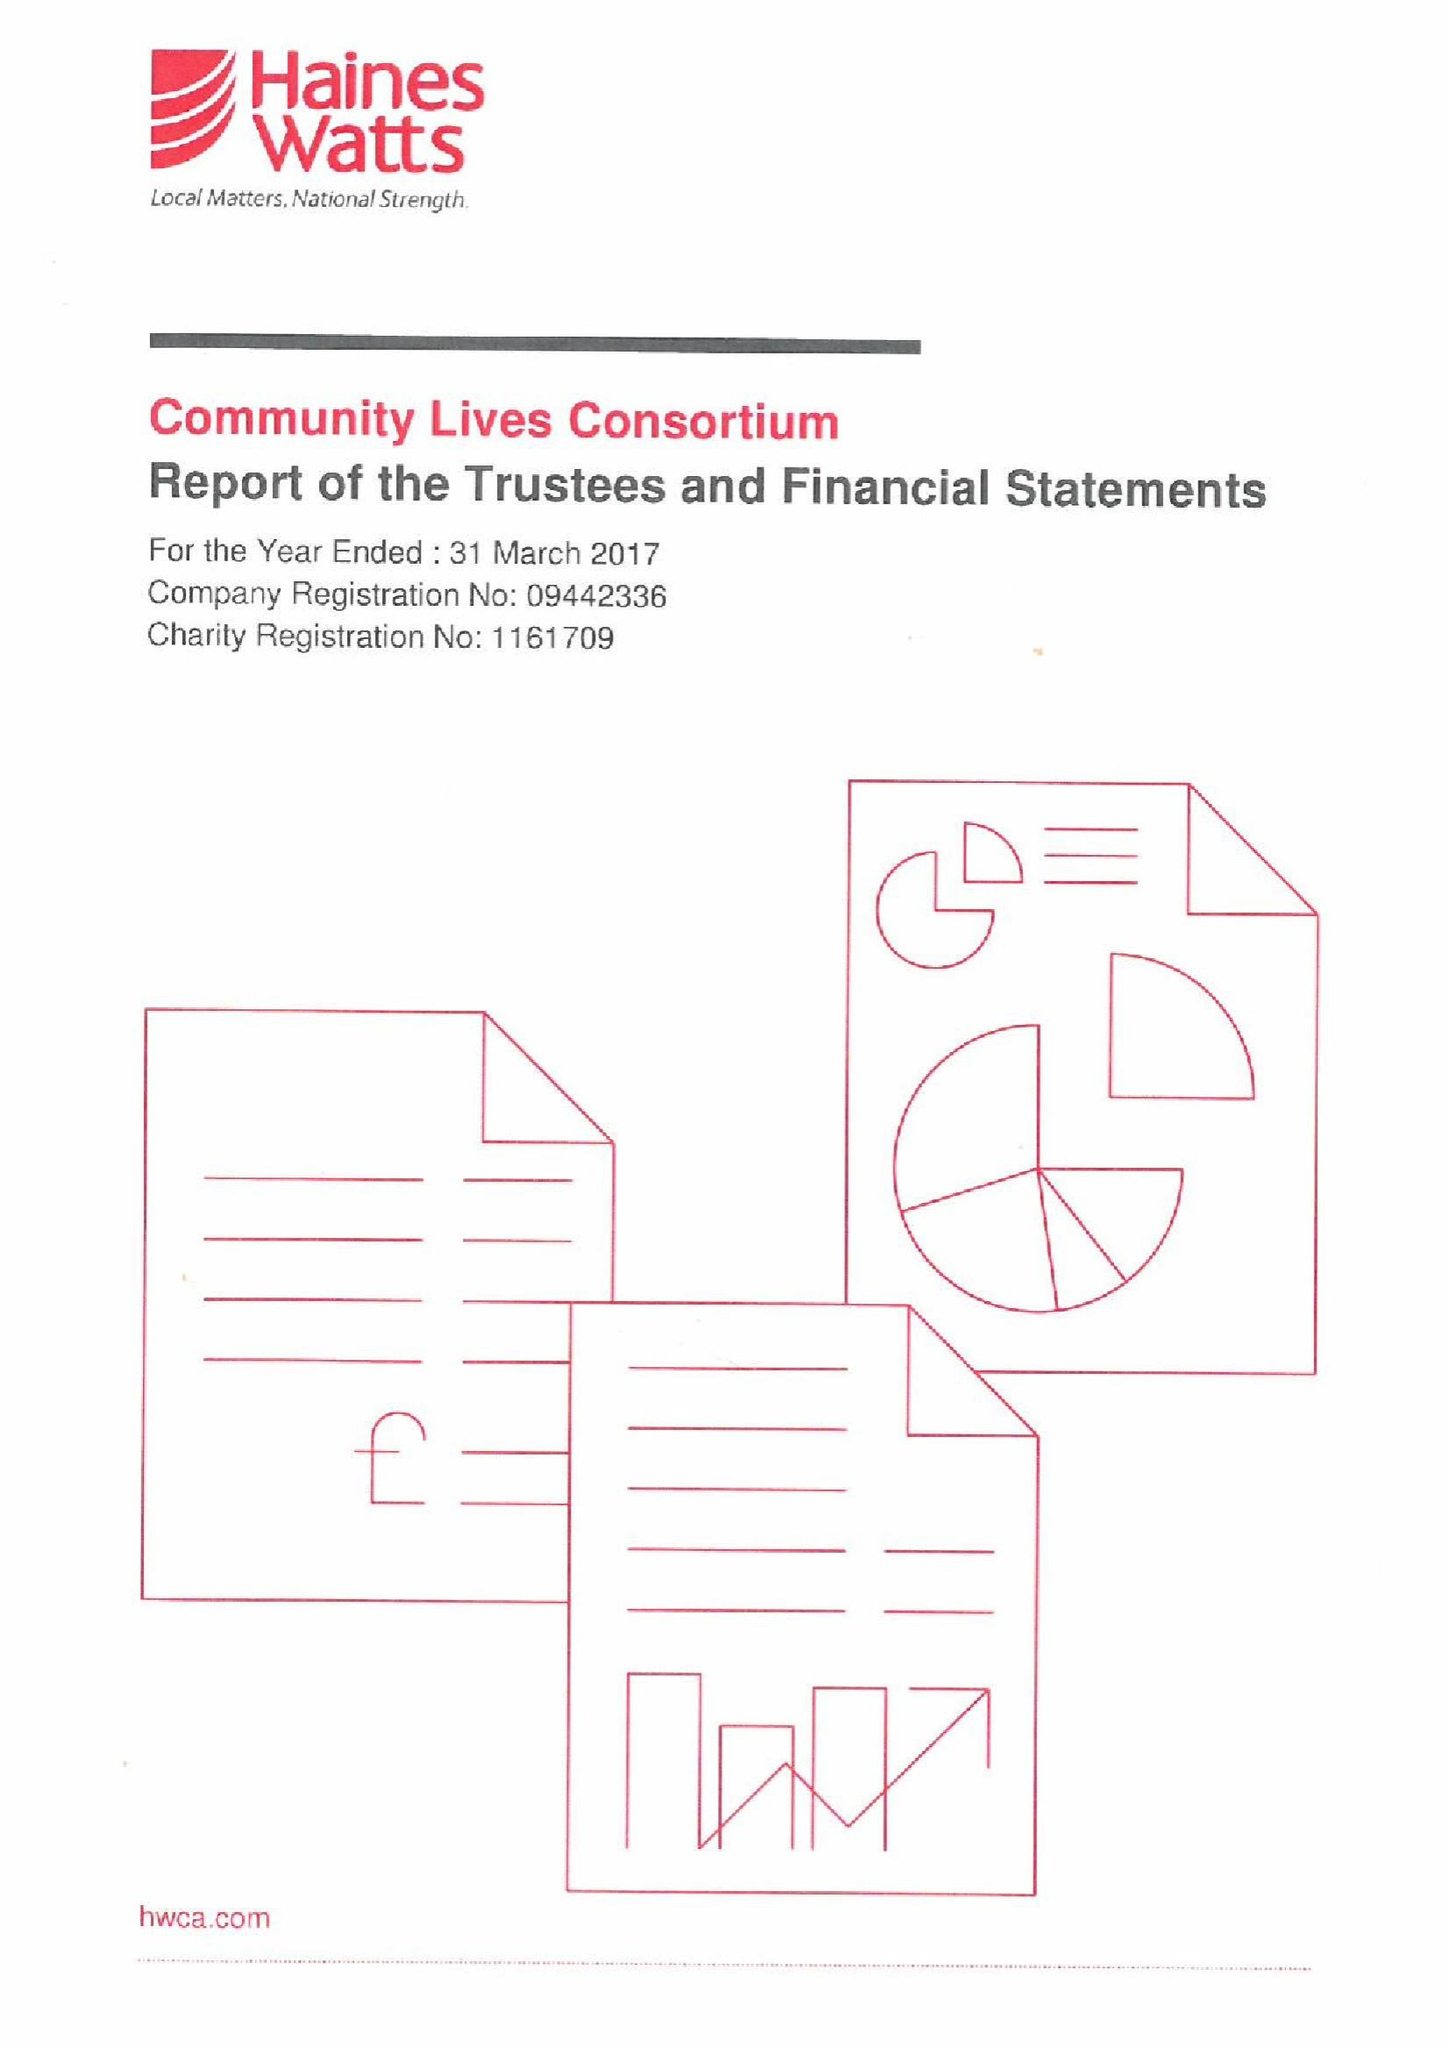What is the value for the address__postcode?
Answer the question using a single word or phrase. SA1 5NN 